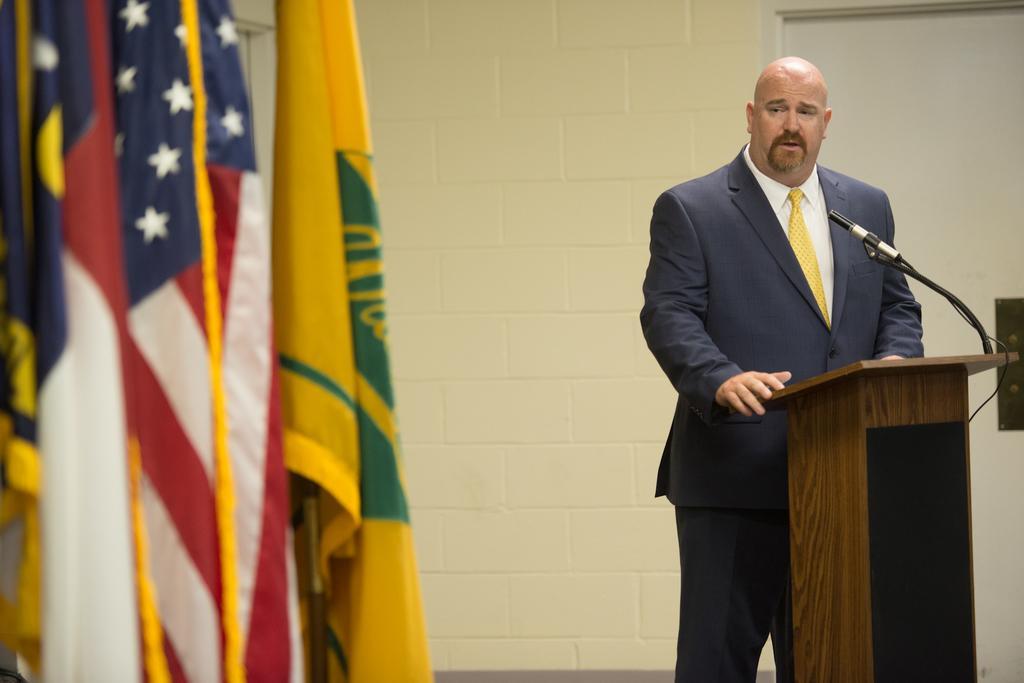In one or two sentences, can you explain what this image depicts? In this image we can see a person standing in front of the podium, on the podium, we can see a mic, there are some flags and also we can see a door and the wall. 